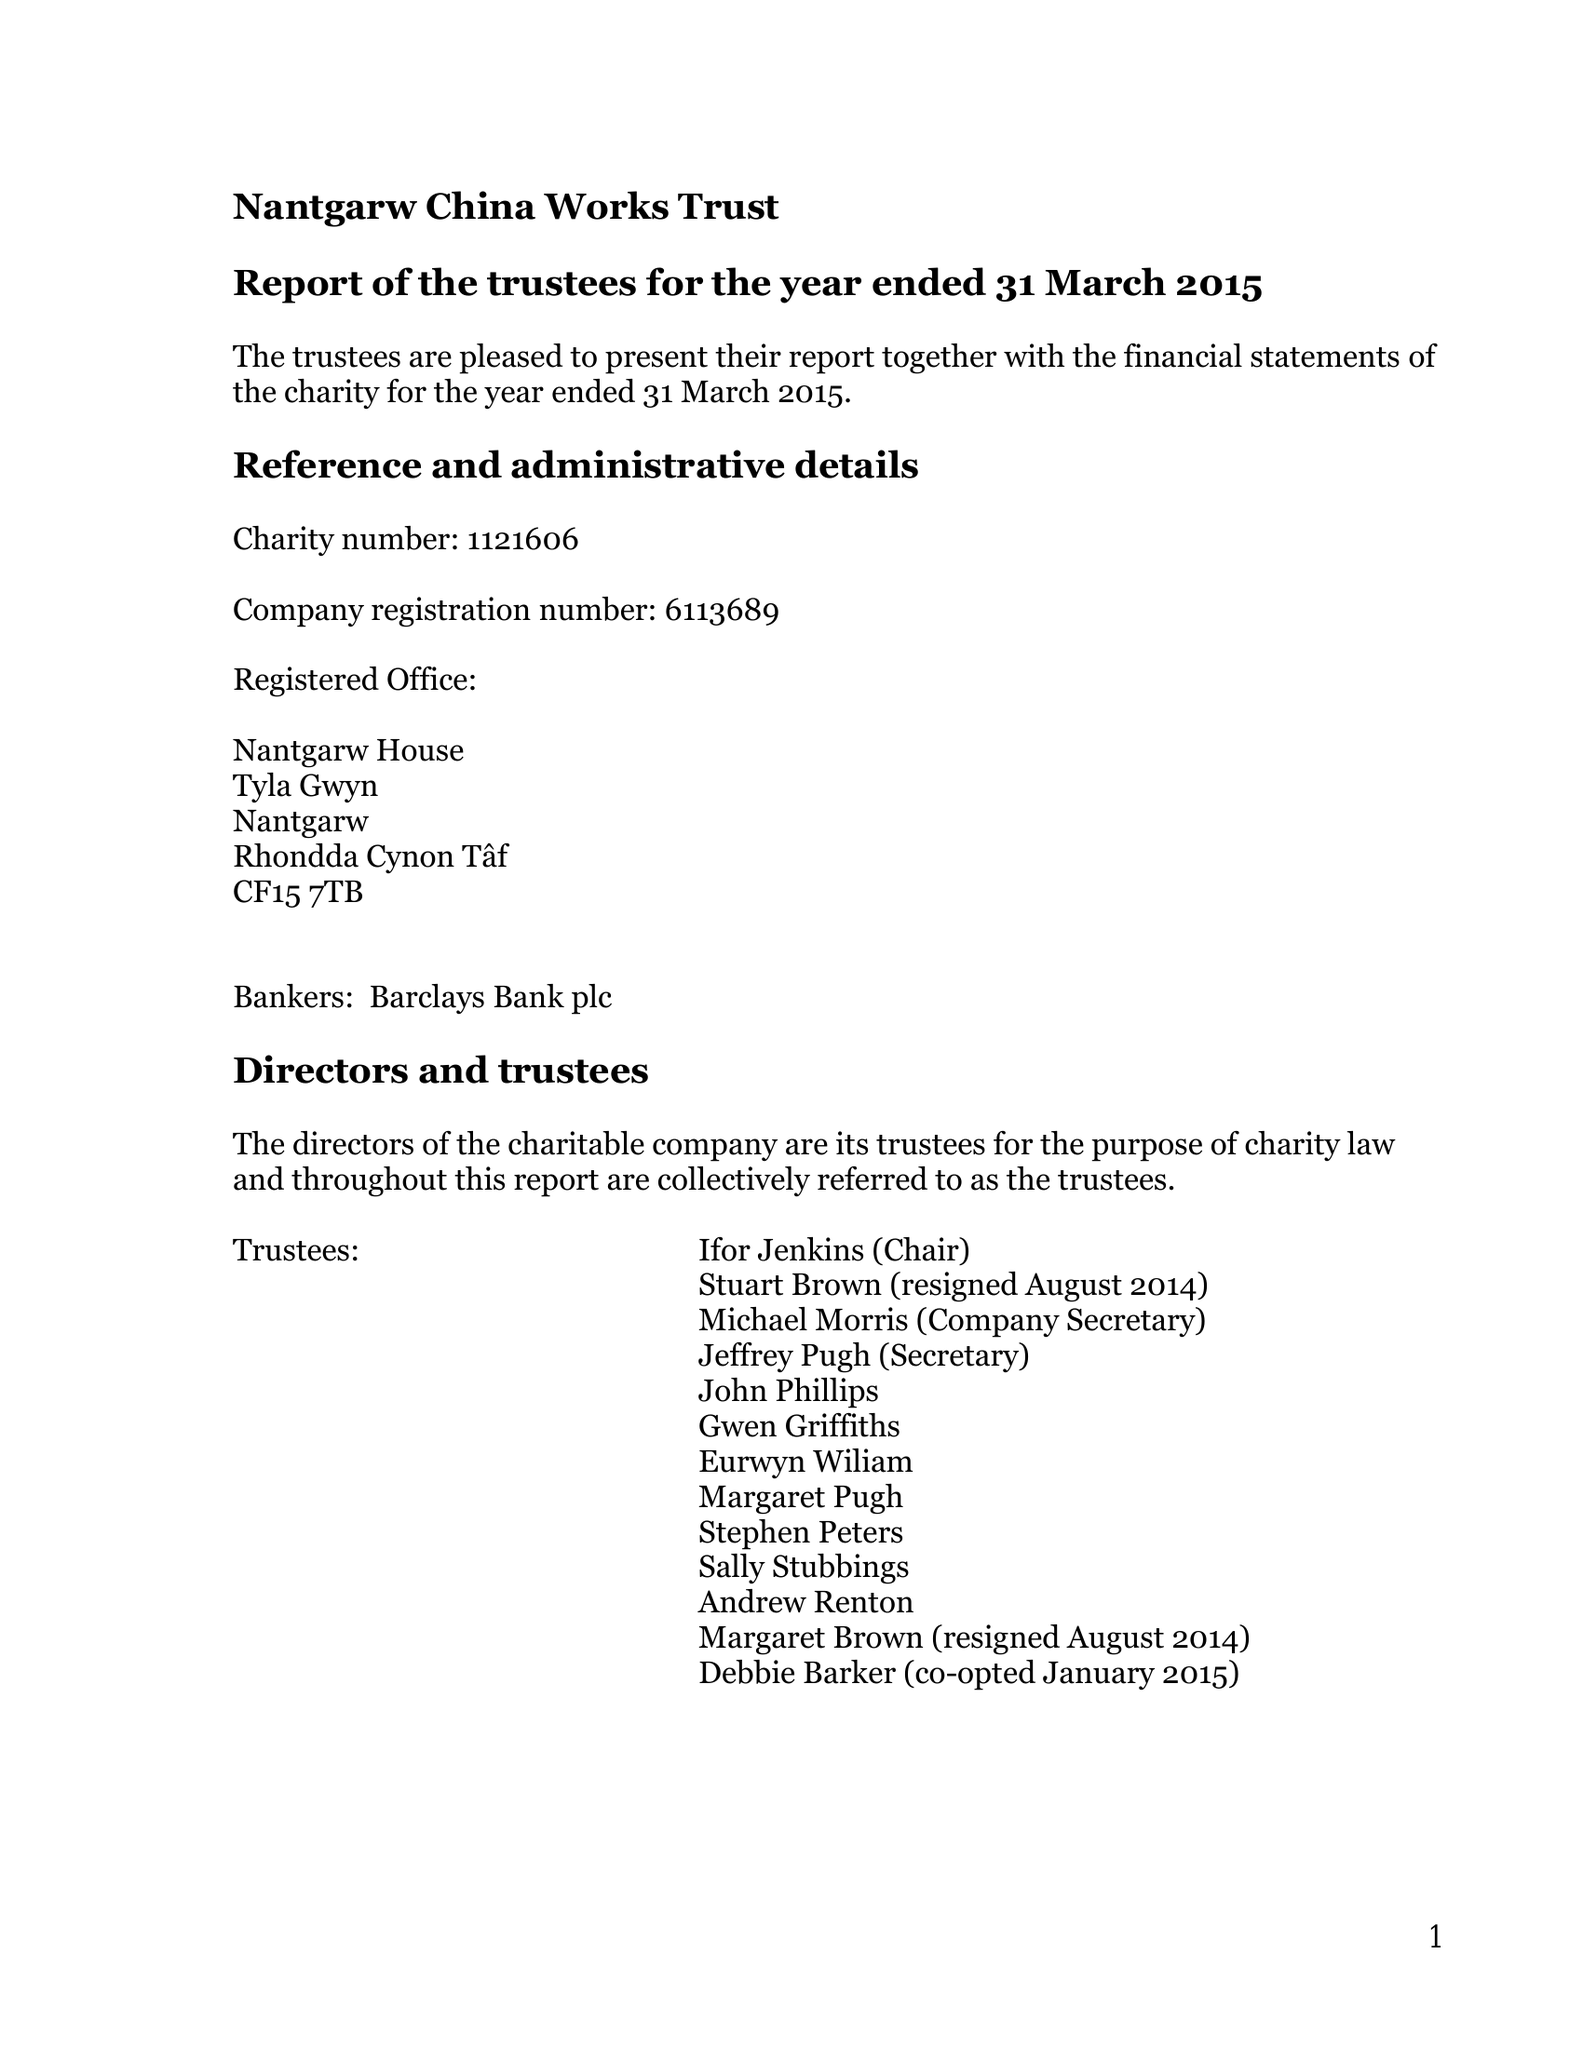What is the value for the address__postcode?
Answer the question using a single word or phrase. CF15 7TB 